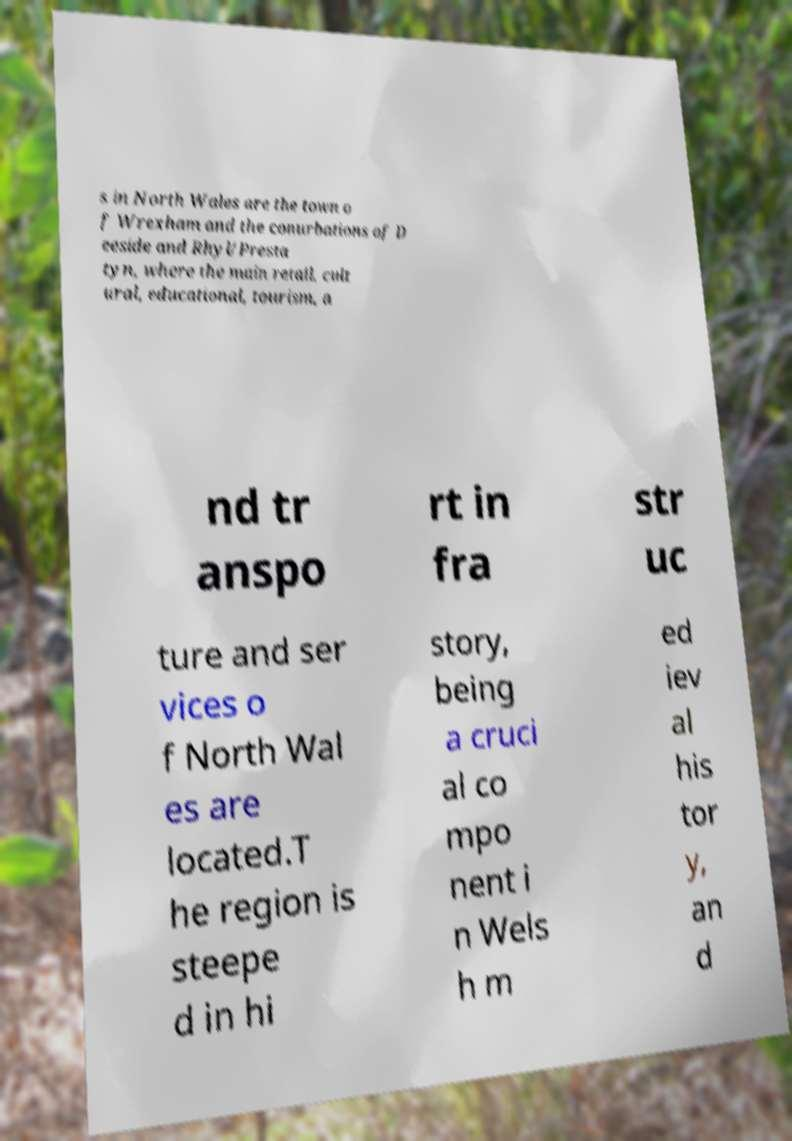Can you read and provide the text displayed in the image?This photo seems to have some interesting text. Can you extract and type it out for me? s in North Wales are the town o f Wrexham and the conurbations of D eeside and Rhyl/Presta tyn, where the main retail, cult ural, educational, tourism, a nd tr anspo rt in fra str uc ture and ser vices o f North Wal es are located.T he region is steepe d in hi story, being a cruci al co mpo nent i n Wels h m ed iev al his tor y, an d 